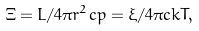<formula> <loc_0><loc_0><loc_500><loc_500>\Xi = L / 4 \pi r ^ { 2 } c p = \xi / 4 \pi c k T ,</formula> 